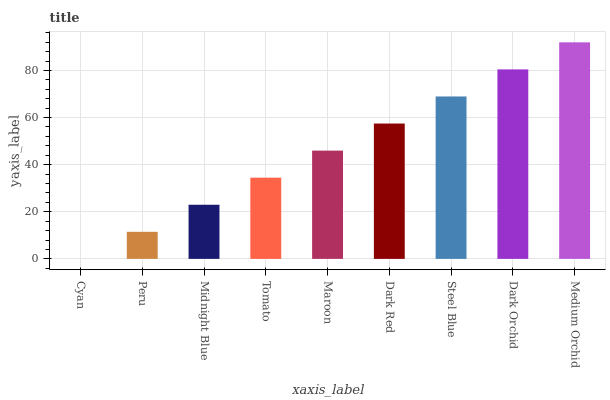Is Peru the minimum?
Answer yes or no. No. Is Peru the maximum?
Answer yes or no. No. Is Peru greater than Cyan?
Answer yes or no. Yes. Is Cyan less than Peru?
Answer yes or no. Yes. Is Cyan greater than Peru?
Answer yes or no. No. Is Peru less than Cyan?
Answer yes or no. No. Is Maroon the high median?
Answer yes or no. Yes. Is Maroon the low median?
Answer yes or no. Yes. Is Tomato the high median?
Answer yes or no. No. Is Tomato the low median?
Answer yes or no. No. 